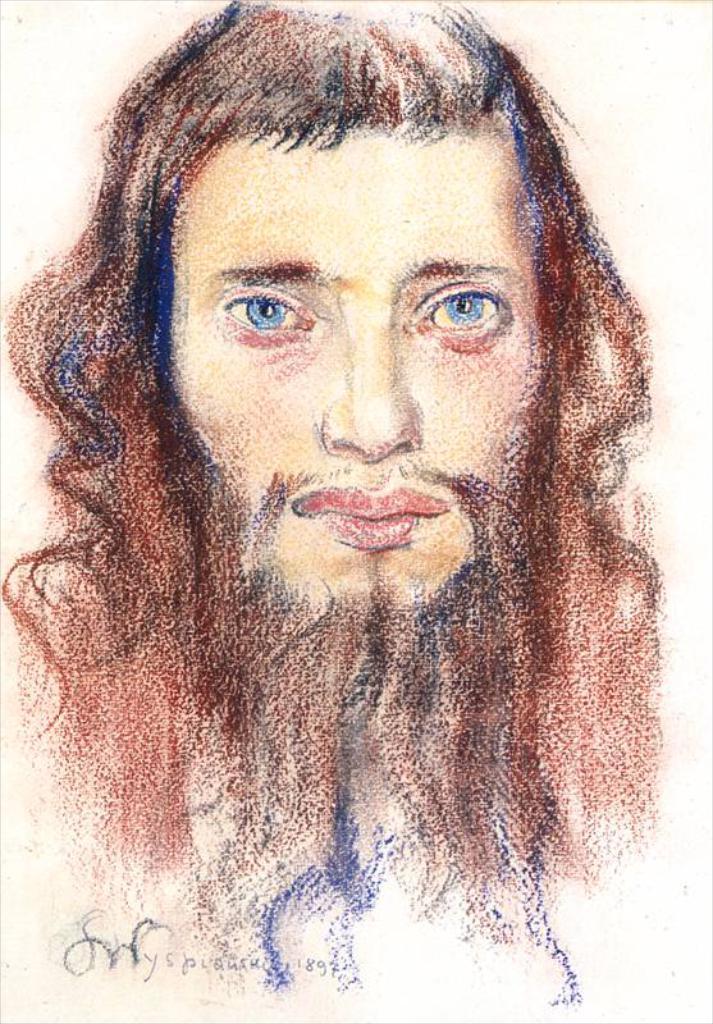How would you summarize this image in a sentence or two? In this picture, we can see an art and some text at bottom side of the picture. 